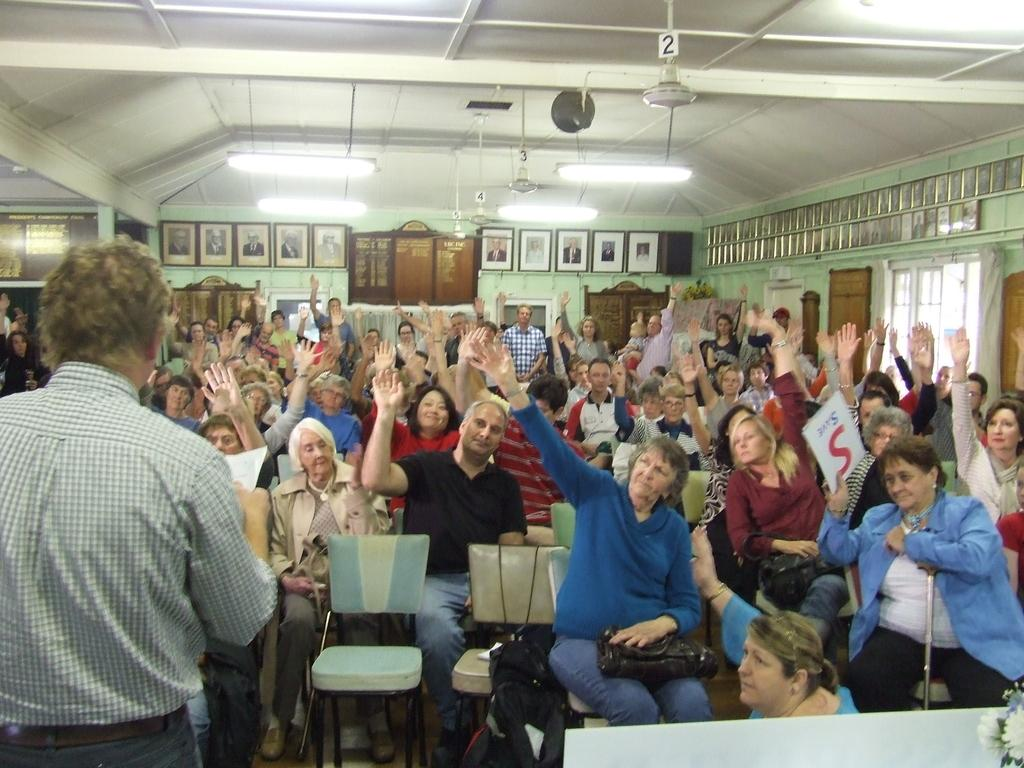What are the people in the image doing? There is a group of people seated in the image. What is the man in the image doing? The man is standing in the image and holding a paper in his hand. What type of furniture is present in the image? There are chairs in the image. What can be seen on the wall in the image? There are photo frames on the wall in the image. What type of clouds can be seen in the image? There are no clouds visible in the image. How does the man maintain his balance while holding the paper in the image? The man's balance is not mentioned in the image, as the focus is on his action of holding a paper. 